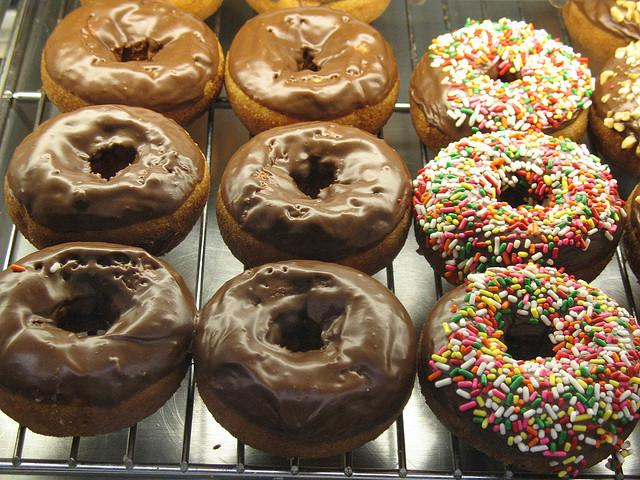These items are usually eaten for what? breakfast 